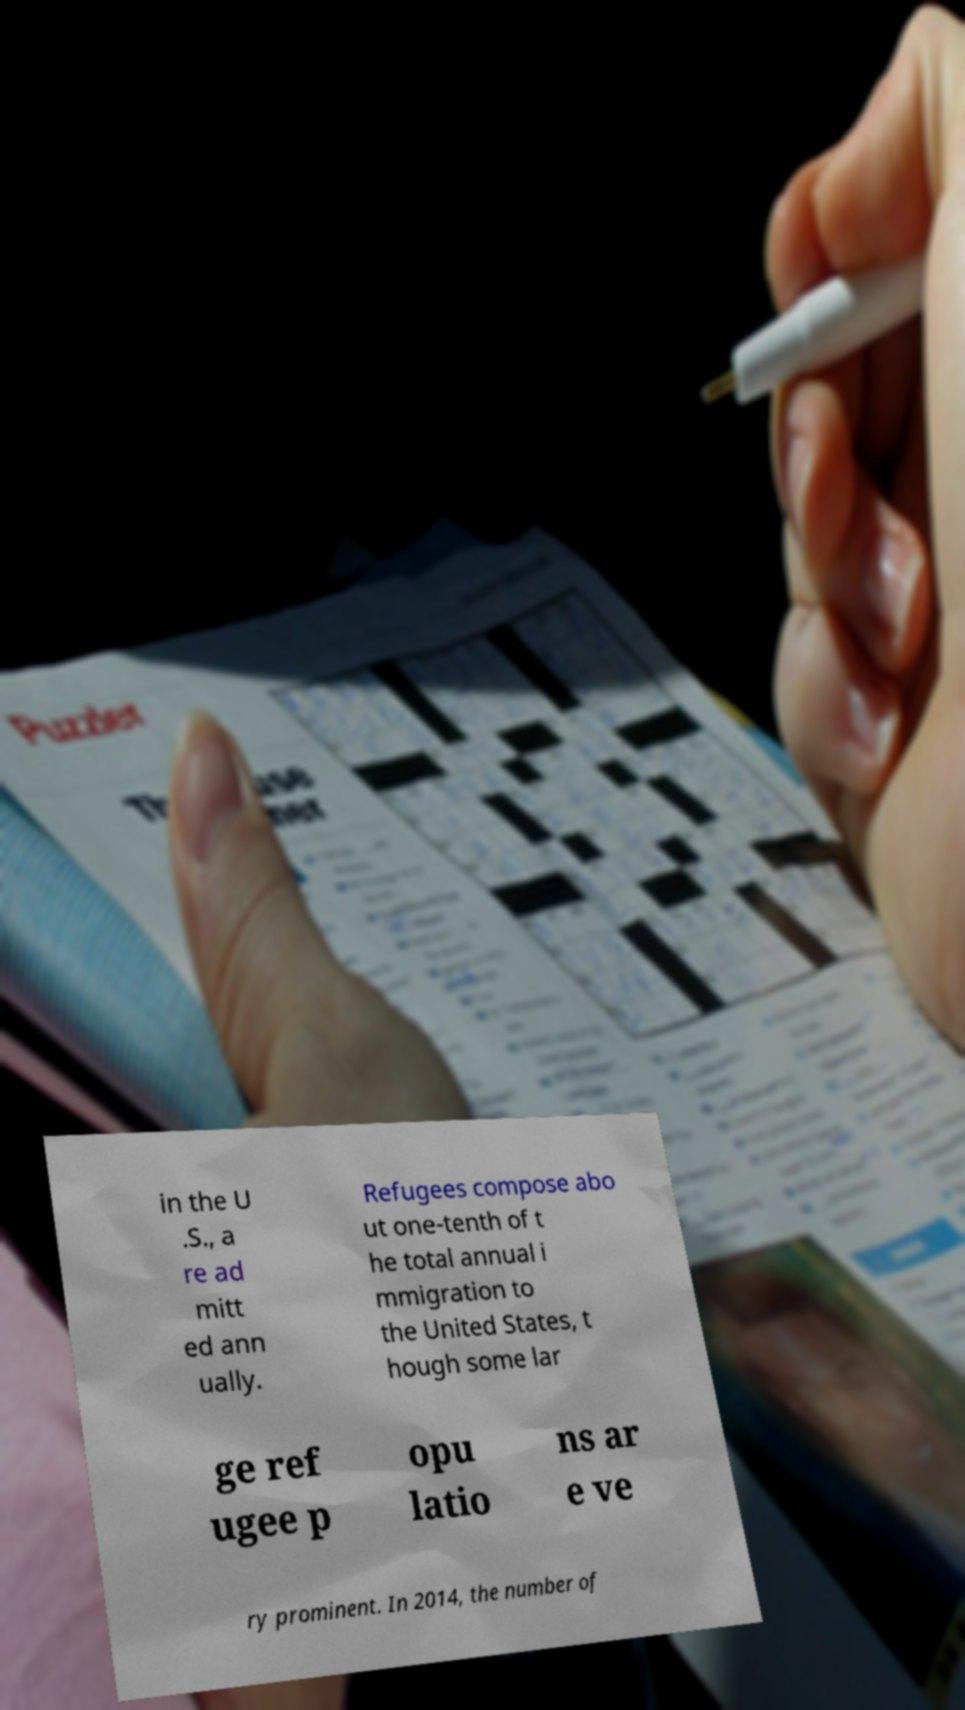I need the written content from this picture converted into text. Can you do that? in the U .S., a re ad mitt ed ann ually. Refugees compose abo ut one-tenth of t he total annual i mmigration to the United States, t hough some lar ge ref ugee p opu latio ns ar e ve ry prominent. In 2014, the number of 